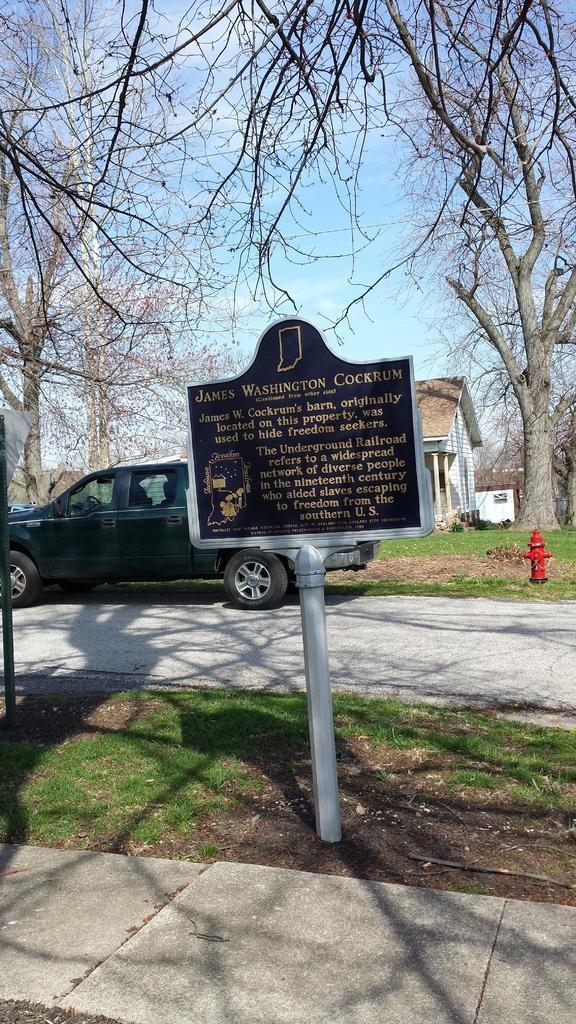Please provide a concise description of this image. In this picture in the center there is a board with some text written on it and there is grass on the ground. In the background there is a car which is black in colour, there is a fire hydrant, there are trees and there are houses and we can see clouds in the sky. 